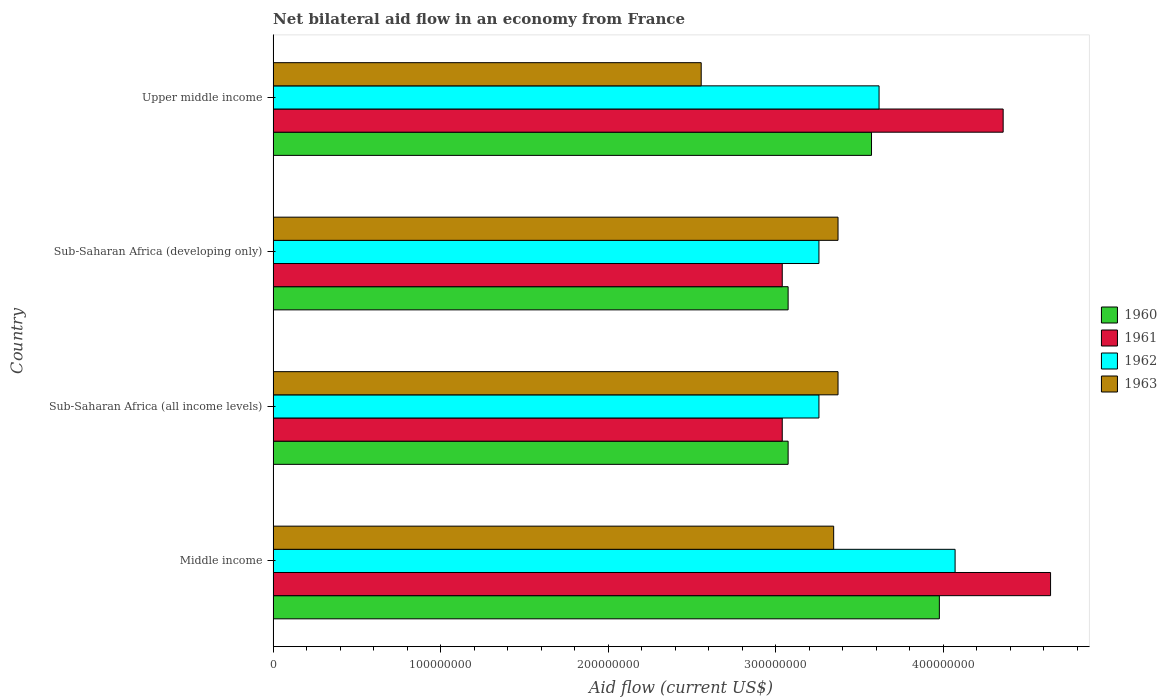How many groups of bars are there?
Your response must be concise. 4. Are the number of bars per tick equal to the number of legend labels?
Keep it short and to the point. Yes. Are the number of bars on each tick of the Y-axis equal?
Your answer should be compact. Yes. How many bars are there on the 3rd tick from the bottom?
Your response must be concise. 4. What is the label of the 4th group of bars from the top?
Ensure brevity in your answer.  Middle income. What is the net bilateral aid flow in 1960 in Middle income?
Ensure brevity in your answer.  3.98e+08. Across all countries, what is the maximum net bilateral aid flow in 1962?
Your response must be concise. 4.07e+08. Across all countries, what is the minimum net bilateral aid flow in 1961?
Provide a succinct answer. 3.04e+08. In which country was the net bilateral aid flow in 1963 maximum?
Give a very brief answer. Sub-Saharan Africa (all income levels). In which country was the net bilateral aid flow in 1961 minimum?
Your response must be concise. Sub-Saharan Africa (all income levels). What is the total net bilateral aid flow in 1963 in the graph?
Your answer should be very brief. 1.26e+09. What is the difference between the net bilateral aid flow in 1961 in Middle income and that in Upper middle income?
Offer a very short reply. 2.83e+07. What is the difference between the net bilateral aid flow in 1962 in Middle income and the net bilateral aid flow in 1963 in Upper middle income?
Make the answer very short. 1.52e+08. What is the average net bilateral aid flow in 1962 per country?
Provide a succinct answer. 3.55e+08. What is the difference between the net bilateral aid flow in 1960 and net bilateral aid flow in 1962 in Middle income?
Your answer should be compact. -9.40e+06. Is the net bilateral aid flow in 1962 in Middle income less than that in Upper middle income?
Offer a very short reply. No. Is the difference between the net bilateral aid flow in 1960 in Sub-Saharan Africa (developing only) and Upper middle income greater than the difference between the net bilateral aid flow in 1962 in Sub-Saharan Africa (developing only) and Upper middle income?
Your response must be concise. No. What is the difference between the highest and the second highest net bilateral aid flow in 1961?
Ensure brevity in your answer.  2.83e+07. What is the difference between the highest and the lowest net bilateral aid flow in 1962?
Offer a very short reply. 8.13e+07. In how many countries, is the net bilateral aid flow in 1960 greater than the average net bilateral aid flow in 1960 taken over all countries?
Provide a short and direct response. 2. Is it the case that in every country, the sum of the net bilateral aid flow in 1963 and net bilateral aid flow in 1960 is greater than the sum of net bilateral aid flow in 1961 and net bilateral aid flow in 1962?
Give a very brief answer. No. Is it the case that in every country, the sum of the net bilateral aid flow in 1960 and net bilateral aid flow in 1962 is greater than the net bilateral aid flow in 1961?
Offer a very short reply. Yes. How many bars are there?
Keep it short and to the point. 16. Are all the bars in the graph horizontal?
Your answer should be compact. Yes. How many countries are there in the graph?
Provide a short and direct response. 4. Are the values on the major ticks of X-axis written in scientific E-notation?
Your response must be concise. No. Does the graph contain any zero values?
Make the answer very short. No. Where does the legend appear in the graph?
Your response must be concise. Center right. How many legend labels are there?
Offer a terse response. 4. How are the legend labels stacked?
Your answer should be very brief. Vertical. What is the title of the graph?
Your response must be concise. Net bilateral aid flow in an economy from France. Does "1961" appear as one of the legend labels in the graph?
Provide a short and direct response. Yes. What is the Aid flow (current US$) of 1960 in Middle income?
Give a very brief answer. 3.98e+08. What is the Aid flow (current US$) of 1961 in Middle income?
Your answer should be compact. 4.64e+08. What is the Aid flow (current US$) in 1962 in Middle income?
Offer a very short reply. 4.07e+08. What is the Aid flow (current US$) in 1963 in Middle income?
Your response must be concise. 3.35e+08. What is the Aid flow (current US$) in 1960 in Sub-Saharan Africa (all income levels)?
Your answer should be compact. 3.08e+08. What is the Aid flow (current US$) of 1961 in Sub-Saharan Africa (all income levels)?
Your answer should be very brief. 3.04e+08. What is the Aid flow (current US$) of 1962 in Sub-Saharan Africa (all income levels)?
Ensure brevity in your answer.  3.26e+08. What is the Aid flow (current US$) in 1963 in Sub-Saharan Africa (all income levels)?
Provide a short and direct response. 3.37e+08. What is the Aid flow (current US$) in 1960 in Sub-Saharan Africa (developing only)?
Provide a succinct answer. 3.08e+08. What is the Aid flow (current US$) in 1961 in Sub-Saharan Africa (developing only)?
Ensure brevity in your answer.  3.04e+08. What is the Aid flow (current US$) of 1962 in Sub-Saharan Africa (developing only)?
Your answer should be very brief. 3.26e+08. What is the Aid flow (current US$) of 1963 in Sub-Saharan Africa (developing only)?
Offer a terse response. 3.37e+08. What is the Aid flow (current US$) in 1960 in Upper middle income?
Offer a very short reply. 3.57e+08. What is the Aid flow (current US$) in 1961 in Upper middle income?
Your answer should be very brief. 4.36e+08. What is the Aid flow (current US$) of 1962 in Upper middle income?
Provide a short and direct response. 3.62e+08. What is the Aid flow (current US$) of 1963 in Upper middle income?
Offer a terse response. 2.56e+08. Across all countries, what is the maximum Aid flow (current US$) of 1960?
Make the answer very short. 3.98e+08. Across all countries, what is the maximum Aid flow (current US$) of 1961?
Provide a succinct answer. 4.64e+08. Across all countries, what is the maximum Aid flow (current US$) of 1962?
Provide a succinct answer. 4.07e+08. Across all countries, what is the maximum Aid flow (current US$) in 1963?
Make the answer very short. 3.37e+08. Across all countries, what is the minimum Aid flow (current US$) in 1960?
Provide a short and direct response. 3.08e+08. Across all countries, what is the minimum Aid flow (current US$) of 1961?
Your answer should be very brief. 3.04e+08. Across all countries, what is the minimum Aid flow (current US$) of 1962?
Offer a terse response. 3.26e+08. Across all countries, what is the minimum Aid flow (current US$) in 1963?
Ensure brevity in your answer.  2.56e+08. What is the total Aid flow (current US$) of 1960 in the graph?
Offer a terse response. 1.37e+09. What is the total Aid flow (current US$) of 1961 in the graph?
Provide a succinct answer. 1.51e+09. What is the total Aid flow (current US$) in 1962 in the graph?
Ensure brevity in your answer.  1.42e+09. What is the total Aid flow (current US$) in 1963 in the graph?
Give a very brief answer. 1.26e+09. What is the difference between the Aid flow (current US$) in 1960 in Middle income and that in Sub-Saharan Africa (all income levels)?
Your response must be concise. 9.03e+07. What is the difference between the Aid flow (current US$) of 1961 in Middle income and that in Sub-Saharan Africa (all income levels)?
Ensure brevity in your answer.  1.60e+08. What is the difference between the Aid flow (current US$) of 1962 in Middle income and that in Sub-Saharan Africa (all income levels)?
Ensure brevity in your answer.  8.13e+07. What is the difference between the Aid flow (current US$) in 1963 in Middle income and that in Sub-Saharan Africa (all income levels)?
Offer a very short reply. -2.60e+06. What is the difference between the Aid flow (current US$) in 1960 in Middle income and that in Sub-Saharan Africa (developing only)?
Your answer should be very brief. 9.03e+07. What is the difference between the Aid flow (current US$) of 1961 in Middle income and that in Sub-Saharan Africa (developing only)?
Provide a short and direct response. 1.60e+08. What is the difference between the Aid flow (current US$) of 1962 in Middle income and that in Sub-Saharan Africa (developing only)?
Keep it short and to the point. 8.13e+07. What is the difference between the Aid flow (current US$) of 1963 in Middle income and that in Sub-Saharan Africa (developing only)?
Make the answer very short. -2.60e+06. What is the difference between the Aid flow (current US$) in 1960 in Middle income and that in Upper middle income?
Make the answer very short. 4.05e+07. What is the difference between the Aid flow (current US$) in 1961 in Middle income and that in Upper middle income?
Keep it short and to the point. 2.83e+07. What is the difference between the Aid flow (current US$) in 1962 in Middle income and that in Upper middle income?
Keep it short and to the point. 4.54e+07. What is the difference between the Aid flow (current US$) in 1963 in Middle income and that in Upper middle income?
Ensure brevity in your answer.  7.91e+07. What is the difference between the Aid flow (current US$) of 1960 in Sub-Saharan Africa (all income levels) and that in Sub-Saharan Africa (developing only)?
Provide a succinct answer. 0. What is the difference between the Aid flow (current US$) in 1962 in Sub-Saharan Africa (all income levels) and that in Sub-Saharan Africa (developing only)?
Your response must be concise. 0. What is the difference between the Aid flow (current US$) of 1960 in Sub-Saharan Africa (all income levels) and that in Upper middle income?
Your answer should be very brief. -4.98e+07. What is the difference between the Aid flow (current US$) of 1961 in Sub-Saharan Africa (all income levels) and that in Upper middle income?
Make the answer very short. -1.32e+08. What is the difference between the Aid flow (current US$) of 1962 in Sub-Saharan Africa (all income levels) and that in Upper middle income?
Offer a very short reply. -3.59e+07. What is the difference between the Aid flow (current US$) of 1963 in Sub-Saharan Africa (all income levels) and that in Upper middle income?
Give a very brief answer. 8.17e+07. What is the difference between the Aid flow (current US$) of 1960 in Sub-Saharan Africa (developing only) and that in Upper middle income?
Your response must be concise. -4.98e+07. What is the difference between the Aid flow (current US$) in 1961 in Sub-Saharan Africa (developing only) and that in Upper middle income?
Give a very brief answer. -1.32e+08. What is the difference between the Aid flow (current US$) in 1962 in Sub-Saharan Africa (developing only) and that in Upper middle income?
Offer a very short reply. -3.59e+07. What is the difference between the Aid flow (current US$) of 1963 in Sub-Saharan Africa (developing only) and that in Upper middle income?
Provide a succinct answer. 8.17e+07. What is the difference between the Aid flow (current US$) of 1960 in Middle income and the Aid flow (current US$) of 1961 in Sub-Saharan Africa (all income levels)?
Offer a terse response. 9.38e+07. What is the difference between the Aid flow (current US$) of 1960 in Middle income and the Aid flow (current US$) of 1962 in Sub-Saharan Africa (all income levels)?
Keep it short and to the point. 7.19e+07. What is the difference between the Aid flow (current US$) in 1960 in Middle income and the Aid flow (current US$) in 1963 in Sub-Saharan Africa (all income levels)?
Provide a short and direct response. 6.05e+07. What is the difference between the Aid flow (current US$) in 1961 in Middle income and the Aid flow (current US$) in 1962 in Sub-Saharan Africa (all income levels)?
Your response must be concise. 1.38e+08. What is the difference between the Aid flow (current US$) of 1961 in Middle income and the Aid flow (current US$) of 1963 in Sub-Saharan Africa (all income levels)?
Your answer should be very brief. 1.27e+08. What is the difference between the Aid flow (current US$) in 1962 in Middle income and the Aid flow (current US$) in 1963 in Sub-Saharan Africa (all income levels)?
Your answer should be very brief. 6.99e+07. What is the difference between the Aid flow (current US$) of 1960 in Middle income and the Aid flow (current US$) of 1961 in Sub-Saharan Africa (developing only)?
Your response must be concise. 9.38e+07. What is the difference between the Aid flow (current US$) of 1960 in Middle income and the Aid flow (current US$) of 1962 in Sub-Saharan Africa (developing only)?
Offer a very short reply. 7.19e+07. What is the difference between the Aid flow (current US$) of 1960 in Middle income and the Aid flow (current US$) of 1963 in Sub-Saharan Africa (developing only)?
Your answer should be very brief. 6.05e+07. What is the difference between the Aid flow (current US$) of 1961 in Middle income and the Aid flow (current US$) of 1962 in Sub-Saharan Africa (developing only)?
Provide a short and direct response. 1.38e+08. What is the difference between the Aid flow (current US$) of 1961 in Middle income and the Aid flow (current US$) of 1963 in Sub-Saharan Africa (developing only)?
Make the answer very short. 1.27e+08. What is the difference between the Aid flow (current US$) of 1962 in Middle income and the Aid flow (current US$) of 1963 in Sub-Saharan Africa (developing only)?
Offer a terse response. 6.99e+07. What is the difference between the Aid flow (current US$) of 1960 in Middle income and the Aid flow (current US$) of 1961 in Upper middle income?
Provide a succinct answer. -3.81e+07. What is the difference between the Aid flow (current US$) in 1960 in Middle income and the Aid flow (current US$) in 1962 in Upper middle income?
Your answer should be compact. 3.60e+07. What is the difference between the Aid flow (current US$) of 1960 in Middle income and the Aid flow (current US$) of 1963 in Upper middle income?
Ensure brevity in your answer.  1.42e+08. What is the difference between the Aid flow (current US$) in 1961 in Middle income and the Aid flow (current US$) in 1962 in Upper middle income?
Provide a succinct answer. 1.02e+08. What is the difference between the Aid flow (current US$) in 1961 in Middle income and the Aid flow (current US$) in 1963 in Upper middle income?
Give a very brief answer. 2.09e+08. What is the difference between the Aid flow (current US$) of 1962 in Middle income and the Aid flow (current US$) of 1963 in Upper middle income?
Your response must be concise. 1.52e+08. What is the difference between the Aid flow (current US$) of 1960 in Sub-Saharan Africa (all income levels) and the Aid flow (current US$) of 1961 in Sub-Saharan Africa (developing only)?
Ensure brevity in your answer.  3.50e+06. What is the difference between the Aid flow (current US$) in 1960 in Sub-Saharan Africa (all income levels) and the Aid flow (current US$) in 1962 in Sub-Saharan Africa (developing only)?
Make the answer very short. -1.84e+07. What is the difference between the Aid flow (current US$) of 1960 in Sub-Saharan Africa (all income levels) and the Aid flow (current US$) of 1963 in Sub-Saharan Africa (developing only)?
Ensure brevity in your answer.  -2.98e+07. What is the difference between the Aid flow (current US$) in 1961 in Sub-Saharan Africa (all income levels) and the Aid flow (current US$) in 1962 in Sub-Saharan Africa (developing only)?
Your response must be concise. -2.19e+07. What is the difference between the Aid flow (current US$) in 1961 in Sub-Saharan Africa (all income levels) and the Aid flow (current US$) in 1963 in Sub-Saharan Africa (developing only)?
Your answer should be compact. -3.33e+07. What is the difference between the Aid flow (current US$) of 1962 in Sub-Saharan Africa (all income levels) and the Aid flow (current US$) of 1963 in Sub-Saharan Africa (developing only)?
Your answer should be very brief. -1.14e+07. What is the difference between the Aid flow (current US$) in 1960 in Sub-Saharan Africa (all income levels) and the Aid flow (current US$) in 1961 in Upper middle income?
Your answer should be compact. -1.28e+08. What is the difference between the Aid flow (current US$) in 1960 in Sub-Saharan Africa (all income levels) and the Aid flow (current US$) in 1962 in Upper middle income?
Offer a very short reply. -5.43e+07. What is the difference between the Aid flow (current US$) of 1960 in Sub-Saharan Africa (all income levels) and the Aid flow (current US$) of 1963 in Upper middle income?
Give a very brief answer. 5.19e+07. What is the difference between the Aid flow (current US$) in 1961 in Sub-Saharan Africa (all income levels) and the Aid flow (current US$) in 1962 in Upper middle income?
Your response must be concise. -5.78e+07. What is the difference between the Aid flow (current US$) in 1961 in Sub-Saharan Africa (all income levels) and the Aid flow (current US$) in 1963 in Upper middle income?
Provide a short and direct response. 4.84e+07. What is the difference between the Aid flow (current US$) in 1962 in Sub-Saharan Africa (all income levels) and the Aid flow (current US$) in 1963 in Upper middle income?
Provide a succinct answer. 7.03e+07. What is the difference between the Aid flow (current US$) of 1960 in Sub-Saharan Africa (developing only) and the Aid flow (current US$) of 1961 in Upper middle income?
Ensure brevity in your answer.  -1.28e+08. What is the difference between the Aid flow (current US$) of 1960 in Sub-Saharan Africa (developing only) and the Aid flow (current US$) of 1962 in Upper middle income?
Your answer should be very brief. -5.43e+07. What is the difference between the Aid flow (current US$) in 1960 in Sub-Saharan Africa (developing only) and the Aid flow (current US$) in 1963 in Upper middle income?
Make the answer very short. 5.19e+07. What is the difference between the Aid flow (current US$) of 1961 in Sub-Saharan Africa (developing only) and the Aid flow (current US$) of 1962 in Upper middle income?
Give a very brief answer. -5.78e+07. What is the difference between the Aid flow (current US$) in 1961 in Sub-Saharan Africa (developing only) and the Aid flow (current US$) in 1963 in Upper middle income?
Give a very brief answer. 4.84e+07. What is the difference between the Aid flow (current US$) in 1962 in Sub-Saharan Africa (developing only) and the Aid flow (current US$) in 1963 in Upper middle income?
Give a very brief answer. 7.03e+07. What is the average Aid flow (current US$) of 1960 per country?
Your response must be concise. 3.43e+08. What is the average Aid flow (current US$) of 1961 per country?
Keep it short and to the point. 3.77e+08. What is the average Aid flow (current US$) of 1962 per country?
Offer a terse response. 3.55e+08. What is the average Aid flow (current US$) of 1963 per country?
Provide a short and direct response. 3.16e+08. What is the difference between the Aid flow (current US$) in 1960 and Aid flow (current US$) in 1961 in Middle income?
Provide a succinct answer. -6.64e+07. What is the difference between the Aid flow (current US$) in 1960 and Aid flow (current US$) in 1962 in Middle income?
Your answer should be compact. -9.40e+06. What is the difference between the Aid flow (current US$) of 1960 and Aid flow (current US$) of 1963 in Middle income?
Your answer should be very brief. 6.31e+07. What is the difference between the Aid flow (current US$) in 1961 and Aid flow (current US$) in 1962 in Middle income?
Provide a succinct answer. 5.70e+07. What is the difference between the Aid flow (current US$) of 1961 and Aid flow (current US$) of 1963 in Middle income?
Provide a succinct answer. 1.30e+08. What is the difference between the Aid flow (current US$) of 1962 and Aid flow (current US$) of 1963 in Middle income?
Make the answer very short. 7.25e+07. What is the difference between the Aid flow (current US$) in 1960 and Aid flow (current US$) in 1961 in Sub-Saharan Africa (all income levels)?
Give a very brief answer. 3.50e+06. What is the difference between the Aid flow (current US$) in 1960 and Aid flow (current US$) in 1962 in Sub-Saharan Africa (all income levels)?
Keep it short and to the point. -1.84e+07. What is the difference between the Aid flow (current US$) in 1960 and Aid flow (current US$) in 1963 in Sub-Saharan Africa (all income levels)?
Your answer should be compact. -2.98e+07. What is the difference between the Aid flow (current US$) in 1961 and Aid flow (current US$) in 1962 in Sub-Saharan Africa (all income levels)?
Your response must be concise. -2.19e+07. What is the difference between the Aid flow (current US$) of 1961 and Aid flow (current US$) of 1963 in Sub-Saharan Africa (all income levels)?
Keep it short and to the point. -3.33e+07. What is the difference between the Aid flow (current US$) in 1962 and Aid flow (current US$) in 1963 in Sub-Saharan Africa (all income levels)?
Provide a short and direct response. -1.14e+07. What is the difference between the Aid flow (current US$) of 1960 and Aid flow (current US$) of 1961 in Sub-Saharan Africa (developing only)?
Ensure brevity in your answer.  3.50e+06. What is the difference between the Aid flow (current US$) in 1960 and Aid flow (current US$) in 1962 in Sub-Saharan Africa (developing only)?
Your answer should be compact. -1.84e+07. What is the difference between the Aid flow (current US$) of 1960 and Aid flow (current US$) of 1963 in Sub-Saharan Africa (developing only)?
Your response must be concise. -2.98e+07. What is the difference between the Aid flow (current US$) in 1961 and Aid flow (current US$) in 1962 in Sub-Saharan Africa (developing only)?
Provide a short and direct response. -2.19e+07. What is the difference between the Aid flow (current US$) of 1961 and Aid flow (current US$) of 1963 in Sub-Saharan Africa (developing only)?
Ensure brevity in your answer.  -3.33e+07. What is the difference between the Aid flow (current US$) of 1962 and Aid flow (current US$) of 1963 in Sub-Saharan Africa (developing only)?
Your answer should be very brief. -1.14e+07. What is the difference between the Aid flow (current US$) in 1960 and Aid flow (current US$) in 1961 in Upper middle income?
Offer a very short reply. -7.86e+07. What is the difference between the Aid flow (current US$) of 1960 and Aid flow (current US$) of 1962 in Upper middle income?
Keep it short and to the point. -4.50e+06. What is the difference between the Aid flow (current US$) in 1960 and Aid flow (current US$) in 1963 in Upper middle income?
Offer a very short reply. 1.02e+08. What is the difference between the Aid flow (current US$) in 1961 and Aid flow (current US$) in 1962 in Upper middle income?
Make the answer very short. 7.41e+07. What is the difference between the Aid flow (current US$) in 1961 and Aid flow (current US$) in 1963 in Upper middle income?
Your response must be concise. 1.80e+08. What is the difference between the Aid flow (current US$) in 1962 and Aid flow (current US$) in 1963 in Upper middle income?
Make the answer very short. 1.06e+08. What is the ratio of the Aid flow (current US$) of 1960 in Middle income to that in Sub-Saharan Africa (all income levels)?
Your response must be concise. 1.29. What is the ratio of the Aid flow (current US$) of 1961 in Middle income to that in Sub-Saharan Africa (all income levels)?
Your answer should be compact. 1.53. What is the ratio of the Aid flow (current US$) in 1962 in Middle income to that in Sub-Saharan Africa (all income levels)?
Ensure brevity in your answer.  1.25. What is the ratio of the Aid flow (current US$) in 1960 in Middle income to that in Sub-Saharan Africa (developing only)?
Offer a terse response. 1.29. What is the ratio of the Aid flow (current US$) in 1961 in Middle income to that in Sub-Saharan Africa (developing only)?
Offer a terse response. 1.53. What is the ratio of the Aid flow (current US$) of 1962 in Middle income to that in Sub-Saharan Africa (developing only)?
Give a very brief answer. 1.25. What is the ratio of the Aid flow (current US$) in 1963 in Middle income to that in Sub-Saharan Africa (developing only)?
Your response must be concise. 0.99. What is the ratio of the Aid flow (current US$) in 1960 in Middle income to that in Upper middle income?
Provide a succinct answer. 1.11. What is the ratio of the Aid flow (current US$) in 1961 in Middle income to that in Upper middle income?
Your answer should be very brief. 1.06. What is the ratio of the Aid flow (current US$) in 1962 in Middle income to that in Upper middle income?
Make the answer very short. 1.13. What is the ratio of the Aid flow (current US$) of 1963 in Middle income to that in Upper middle income?
Provide a short and direct response. 1.31. What is the ratio of the Aid flow (current US$) in 1960 in Sub-Saharan Africa (all income levels) to that in Sub-Saharan Africa (developing only)?
Give a very brief answer. 1. What is the ratio of the Aid flow (current US$) of 1963 in Sub-Saharan Africa (all income levels) to that in Sub-Saharan Africa (developing only)?
Make the answer very short. 1. What is the ratio of the Aid flow (current US$) in 1960 in Sub-Saharan Africa (all income levels) to that in Upper middle income?
Keep it short and to the point. 0.86. What is the ratio of the Aid flow (current US$) in 1961 in Sub-Saharan Africa (all income levels) to that in Upper middle income?
Your response must be concise. 0.7. What is the ratio of the Aid flow (current US$) in 1962 in Sub-Saharan Africa (all income levels) to that in Upper middle income?
Your answer should be very brief. 0.9. What is the ratio of the Aid flow (current US$) in 1963 in Sub-Saharan Africa (all income levels) to that in Upper middle income?
Provide a succinct answer. 1.32. What is the ratio of the Aid flow (current US$) of 1960 in Sub-Saharan Africa (developing only) to that in Upper middle income?
Provide a succinct answer. 0.86. What is the ratio of the Aid flow (current US$) in 1961 in Sub-Saharan Africa (developing only) to that in Upper middle income?
Your response must be concise. 0.7. What is the ratio of the Aid flow (current US$) of 1962 in Sub-Saharan Africa (developing only) to that in Upper middle income?
Offer a terse response. 0.9. What is the ratio of the Aid flow (current US$) in 1963 in Sub-Saharan Africa (developing only) to that in Upper middle income?
Your answer should be compact. 1.32. What is the difference between the highest and the second highest Aid flow (current US$) in 1960?
Offer a terse response. 4.05e+07. What is the difference between the highest and the second highest Aid flow (current US$) in 1961?
Ensure brevity in your answer.  2.83e+07. What is the difference between the highest and the second highest Aid flow (current US$) of 1962?
Keep it short and to the point. 4.54e+07. What is the difference between the highest and the second highest Aid flow (current US$) in 1963?
Your answer should be compact. 0. What is the difference between the highest and the lowest Aid flow (current US$) in 1960?
Give a very brief answer. 9.03e+07. What is the difference between the highest and the lowest Aid flow (current US$) in 1961?
Offer a very short reply. 1.60e+08. What is the difference between the highest and the lowest Aid flow (current US$) of 1962?
Keep it short and to the point. 8.13e+07. What is the difference between the highest and the lowest Aid flow (current US$) in 1963?
Make the answer very short. 8.17e+07. 